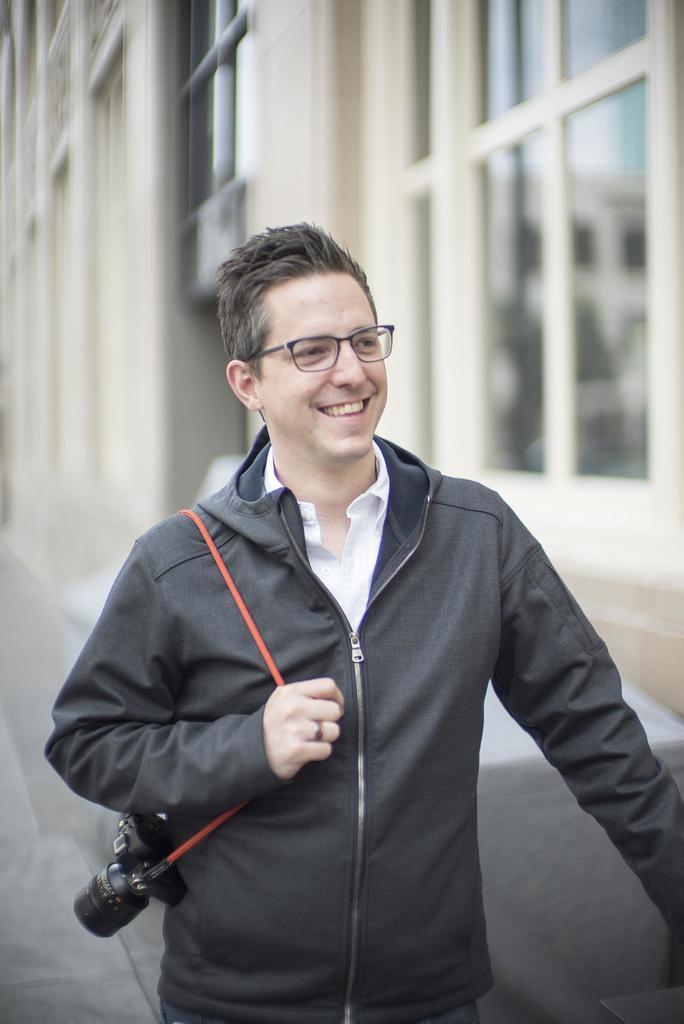Could you give a brief overview of what you see in this image? In this image I can see person is standing and holding camera. He is wearing black coat and white shirt. Back Side I can see building and glass-windows. 